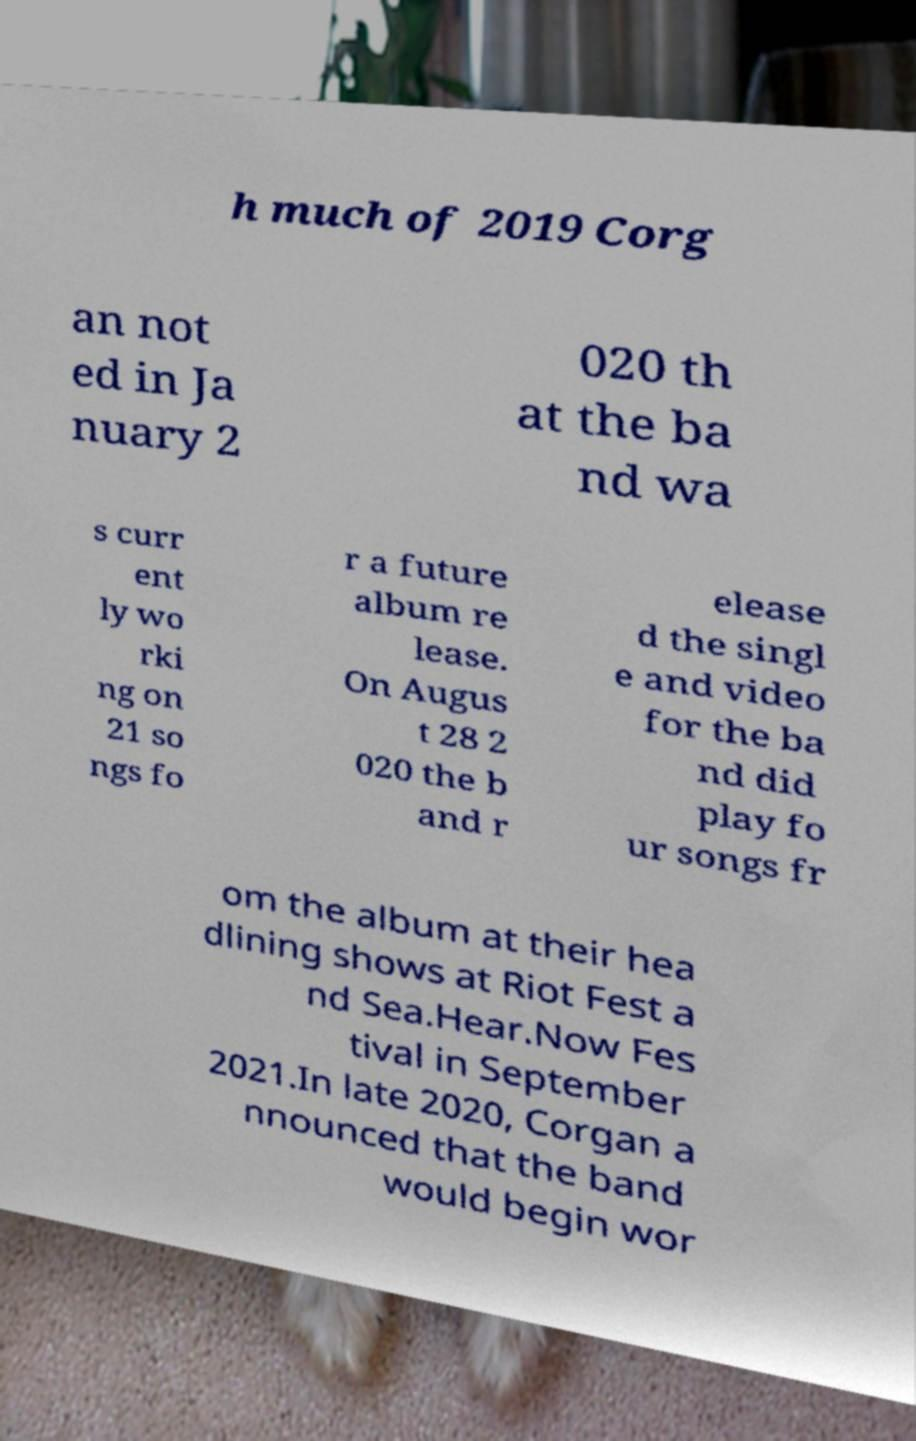Can you read and provide the text displayed in the image?This photo seems to have some interesting text. Can you extract and type it out for me? h much of 2019 Corg an not ed in Ja nuary 2 020 th at the ba nd wa s curr ent ly wo rki ng on 21 so ngs fo r a future album re lease. On Augus t 28 2 020 the b and r elease d the singl e and video for the ba nd did play fo ur songs fr om the album at their hea dlining shows at Riot Fest a nd Sea.Hear.Now Fes tival in September 2021.In late 2020, Corgan a nnounced that the band would begin wor 